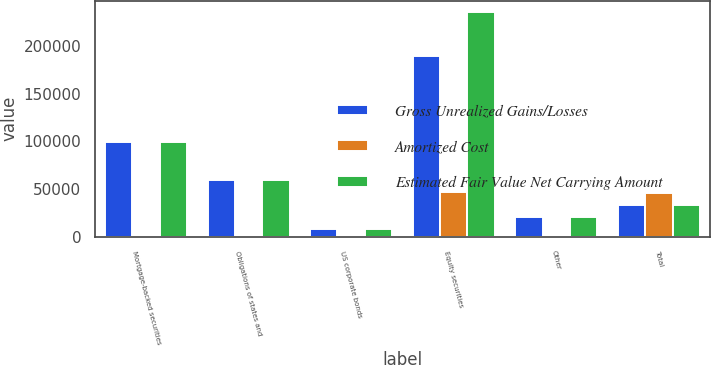Convert chart to OTSL. <chart><loc_0><loc_0><loc_500><loc_500><stacked_bar_chart><ecel><fcel>Mortgage-backed securities<fcel>Obligations of states and<fcel>US corporate bonds<fcel>Equity securities<fcel>Other<fcel>Total<nl><fcel>Gross Unrealized Gains/Losses<fcel>99749<fcel>59497<fcel>8479<fcel>188971<fcel>21333<fcel>33904.5<nl><fcel>Amortized Cost<fcel>68<fcel>158<fcel>219<fcel>46688<fcel>83<fcel>46476<nl><fcel>Estimated Fair Value Net Carrying Amount<fcel>99681<fcel>59655<fcel>8260<fcel>235659<fcel>21250<fcel>33904.5<nl></chart> 